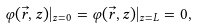<formula> <loc_0><loc_0><loc_500><loc_500>\varphi ( \vec { r } , z ) | _ { z = 0 } = \varphi ( \vec { r } , z ) | _ { z = L } = 0 ,</formula> 